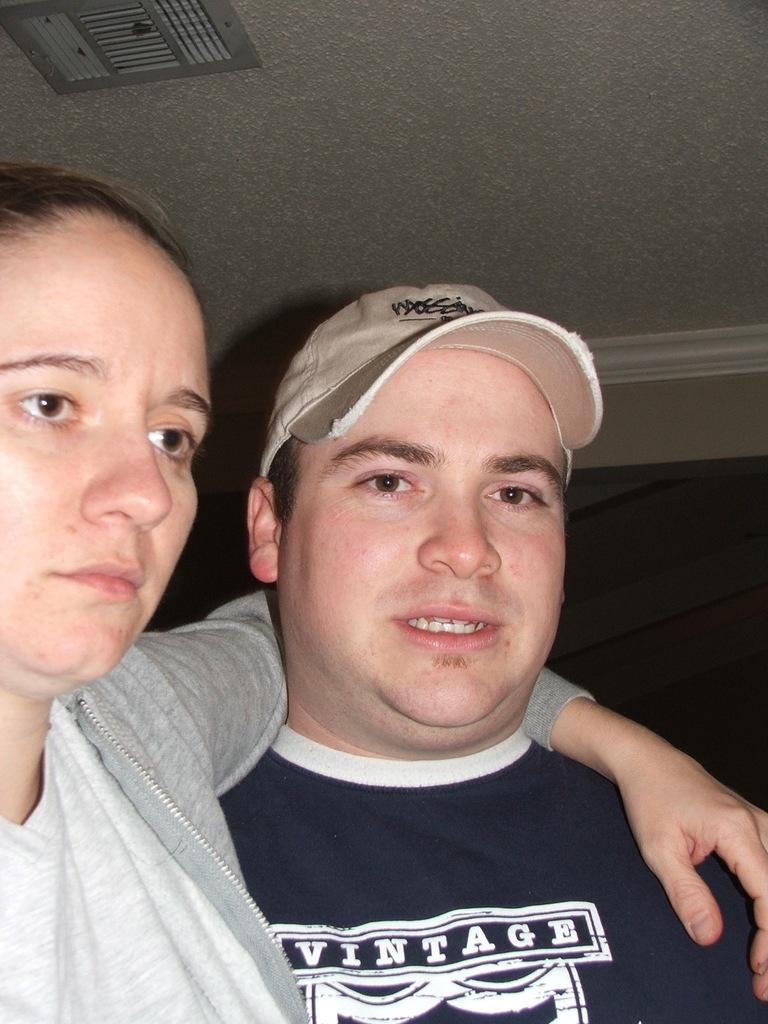<image>
Share a concise interpretation of the image provided. Two people posing for the camera including a man wearing a navy shirt labeled VINTAGE 